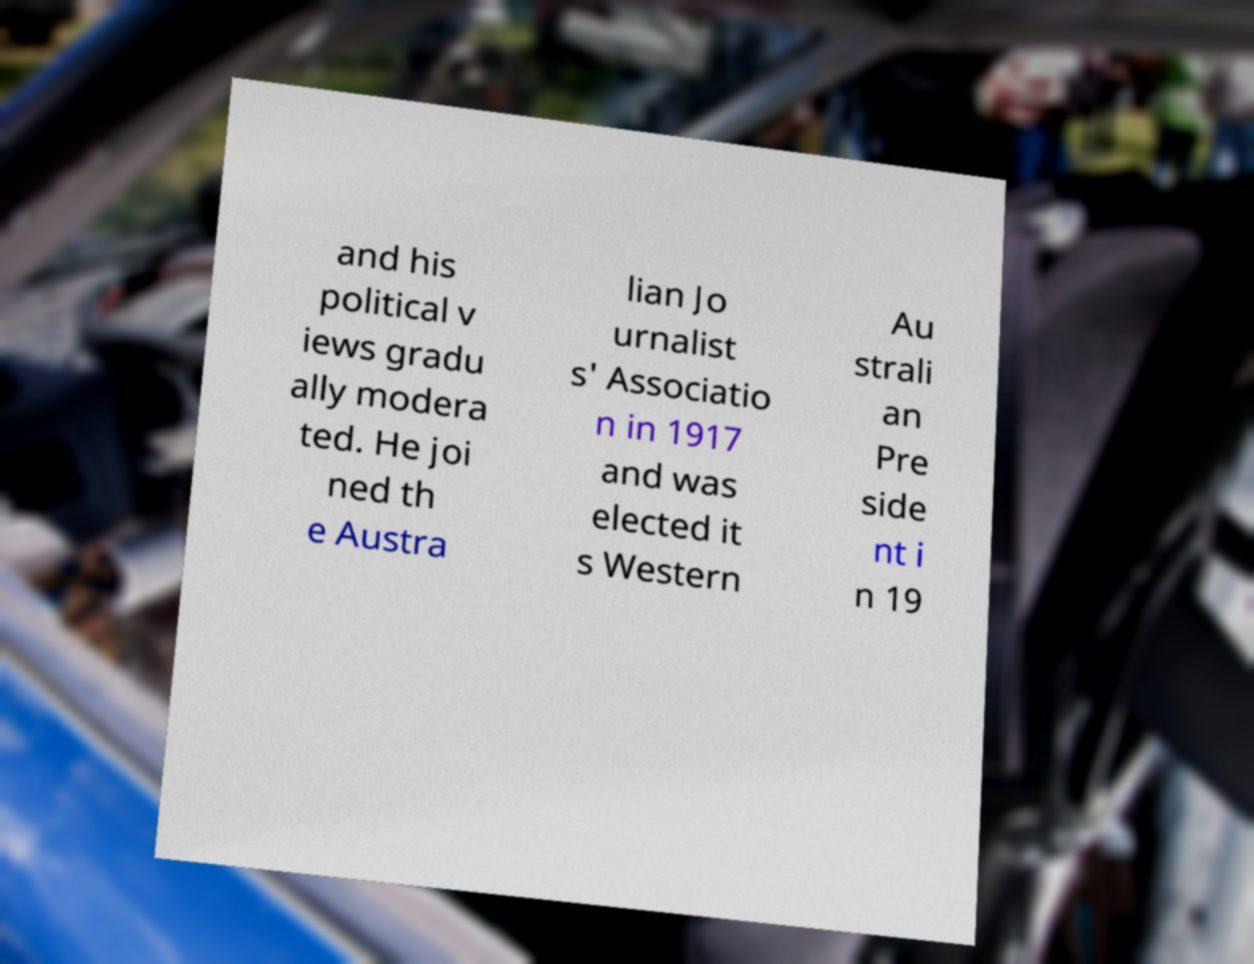For documentation purposes, I need the text within this image transcribed. Could you provide that? and his political v iews gradu ally modera ted. He joi ned th e Austra lian Jo urnalist s' Associatio n in 1917 and was elected it s Western Au strali an Pre side nt i n 19 